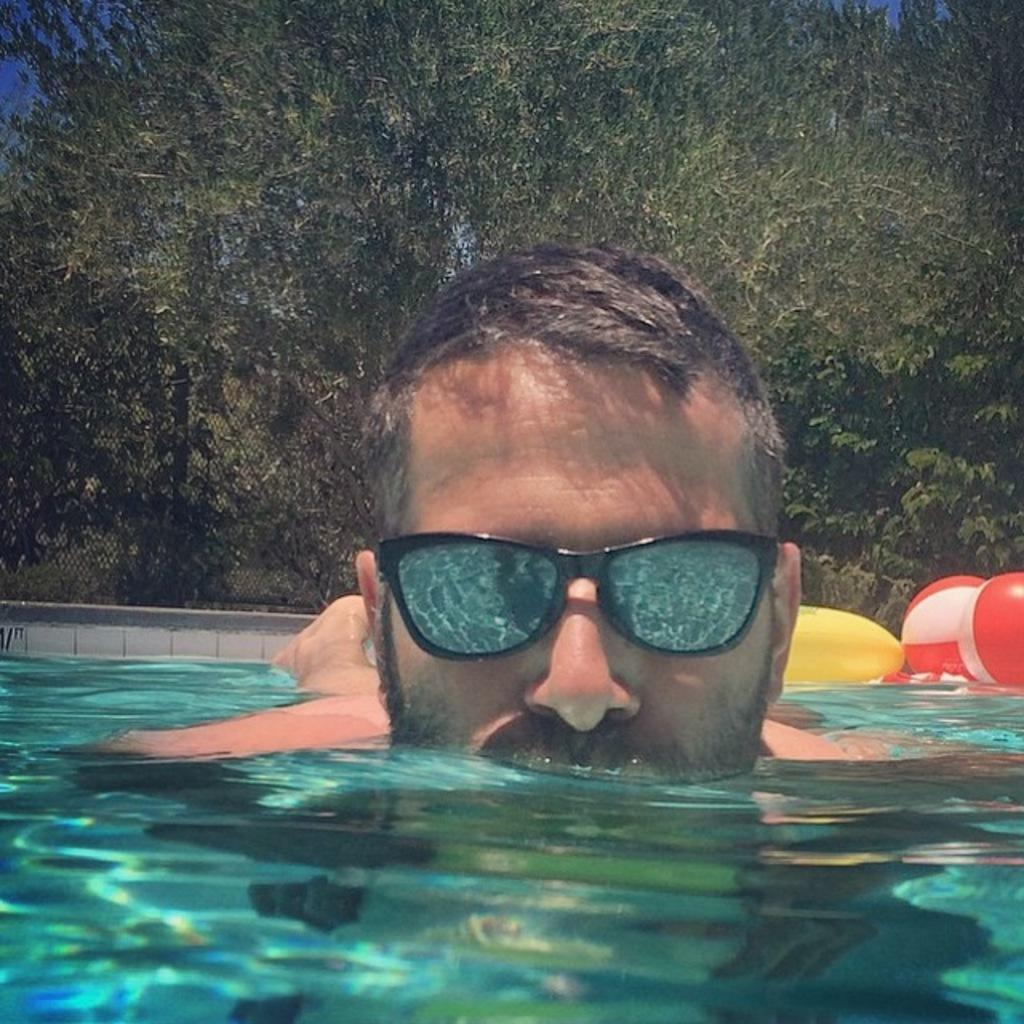What is the primary element visible in the image? There is water in the image. What else can be seen in the water? There are balls in the image. What color is the object that stands out in the image? There is a yellow object in the image. What is the man in the image wearing? The man is wearing goggles in the image. What is visible in the background of the image? There are trees in the background of the image. Where can the man purchase a ticket for the seashore in the image? There is no mention of a seashore or ticket in the image; it only features water, balls, a yellow object, a man wearing goggles, and trees in the background. 